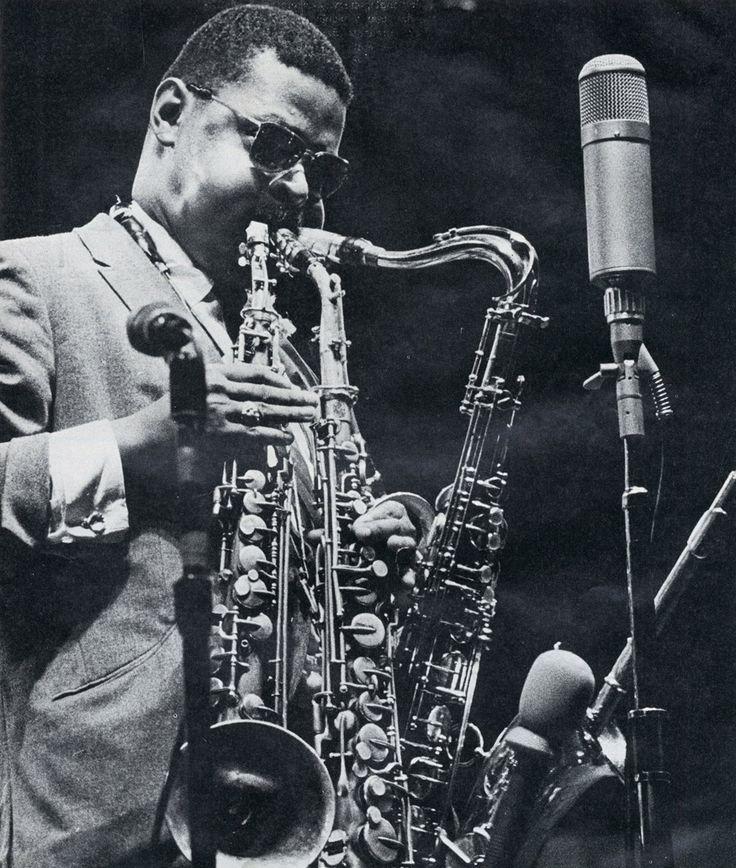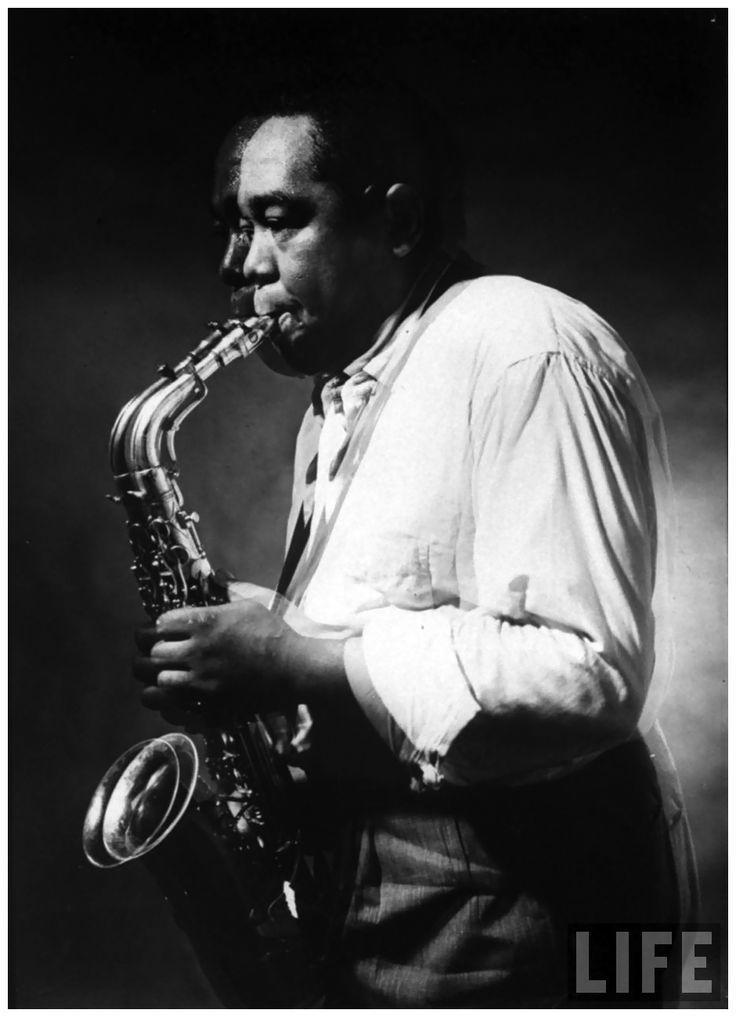The first image is the image on the left, the second image is the image on the right. Evaluate the accuracy of this statement regarding the images: "In one of the pictures a musician is wearing a hat.". Is it true? Answer yes or no. No. The first image is the image on the left, the second image is the image on the right. Considering the images on both sides, is "An image shows a non-black man with bare forearms playing the sax." valid? Answer yes or no. No. 